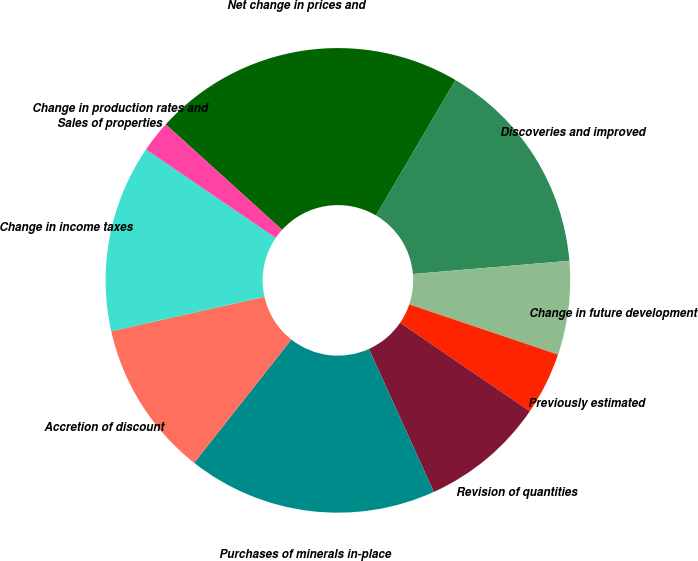<chart> <loc_0><loc_0><loc_500><loc_500><pie_chart><fcel>Net change in prices and<fcel>Discoveries and improved<fcel>Change in future development<fcel>Previously estimated<fcel>Revision of quantities<fcel>Purchases of minerals in-place<fcel>Accretion of discount<fcel>Change in income taxes<fcel>Sales of properties<fcel>Change in production rates and<nl><fcel>21.73%<fcel>15.21%<fcel>6.52%<fcel>4.35%<fcel>8.7%<fcel>17.39%<fcel>10.87%<fcel>13.04%<fcel>0.01%<fcel>2.18%<nl></chart> 